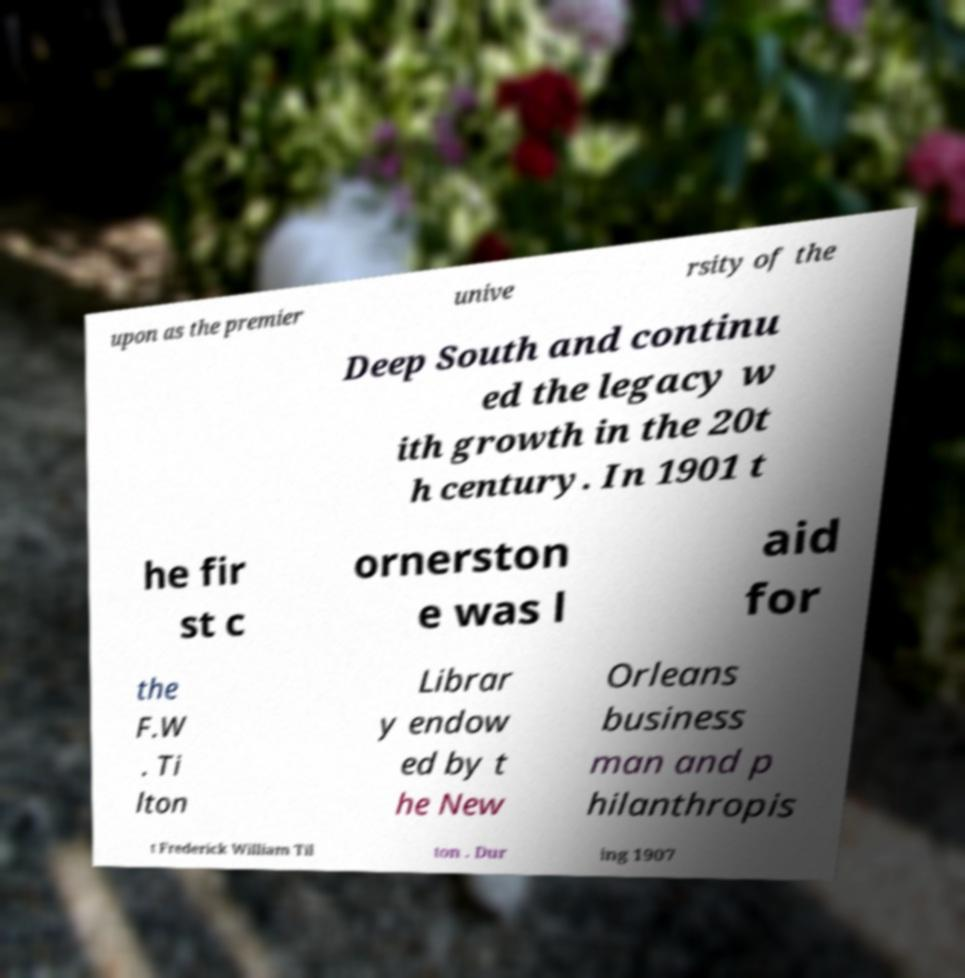There's text embedded in this image that I need extracted. Can you transcribe it verbatim? upon as the premier unive rsity of the Deep South and continu ed the legacy w ith growth in the 20t h century. In 1901 t he fir st c ornerston e was l aid for the F.W . Ti lton Librar y endow ed by t he New Orleans business man and p hilanthropis t Frederick William Til ton . Dur ing 1907 